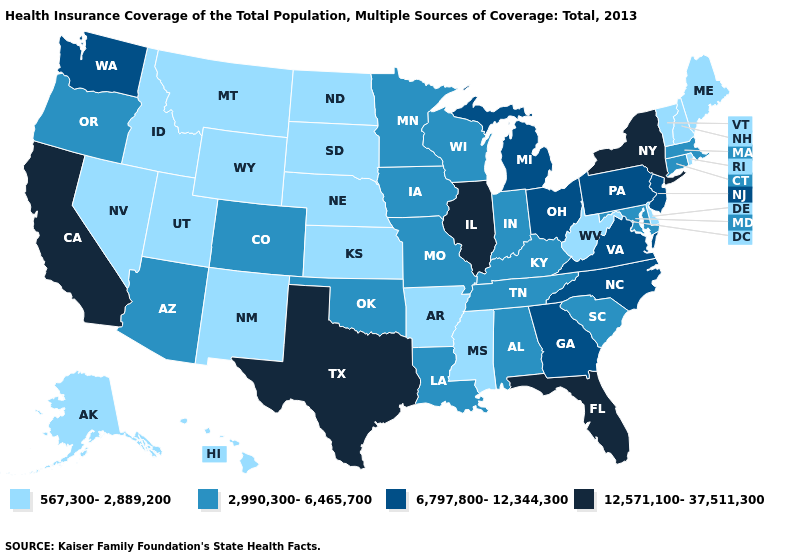What is the highest value in the USA?
Concise answer only. 12,571,100-37,511,300. Does Minnesota have the same value as Utah?
Answer briefly. No. Name the states that have a value in the range 12,571,100-37,511,300?
Keep it brief. California, Florida, Illinois, New York, Texas. How many symbols are there in the legend?
Be succinct. 4. Which states have the highest value in the USA?
Short answer required. California, Florida, Illinois, New York, Texas. What is the highest value in the Northeast ?
Concise answer only. 12,571,100-37,511,300. Name the states that have a value in the range 567,300-2,889,200?
Short answer required. Alaska, Arkansas, Delaware, Hawaii, Idaho, Kansas, Maine, Mississippi, Montana, Nebraska, Nevada, New Hampshire, New Mexico, North Dakota, Rhode Island, South Dakota, Utah, Vermont, West Virginia, Wyoming. What is the lowest value in the USA?
Give a very brief answer. 567,300-2,889,200. Does Delaware have a lower value than Kentucky?
Answer briefly. Yes. Name the states that have a value in the range 567,300-2,889,200?
Be succinct. Alaska, Arkansas, Delaware, Hawaii, Idaho, Kansas, Maine, Mississippi, Montana, Nebraska, Nevada, New Hampshire, New Mexico, North Dakota, Rhode Island, South Dakota, Utah, Vermont, West Virginia, Wyoming. Name the states that have a value in the range 6,797,800-12,344,300?
Keep it brief. Georgia, Michigan, New Jersey, North Carolina, Ohio, Pennsylvania, Virginia, Washington. Does Illinois have the highest value in the MidWest?
Write a very short answer. Yes. What is the value of North Carolina?
Keep it brief. 6,797,800-12,344,300. Among the states that border Idaho , does Washington have the highest value?
Write a very short answer. Yes. Among the states that border Colorado , which have the lowest value?
Keep it brief. Kansas, Nebraska, New Mexico, Utah, Wyoming. 